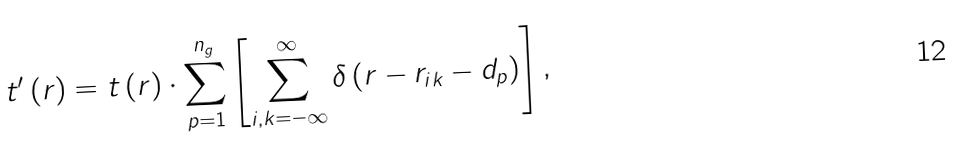<formula> <loc_0><loc_0><loc_500><loc_500>t ^ { \prime } \left ( r \right ) = t \left ( r \right ) \cdot \sum _ { p = 1 } ^ { n _ { g } } \left [ \sum _ { i , k = - \infty } ^ { \infty } \delta \left ( r - r _ { i k } - d _ { p } \right ) \right ] ,</formula> 